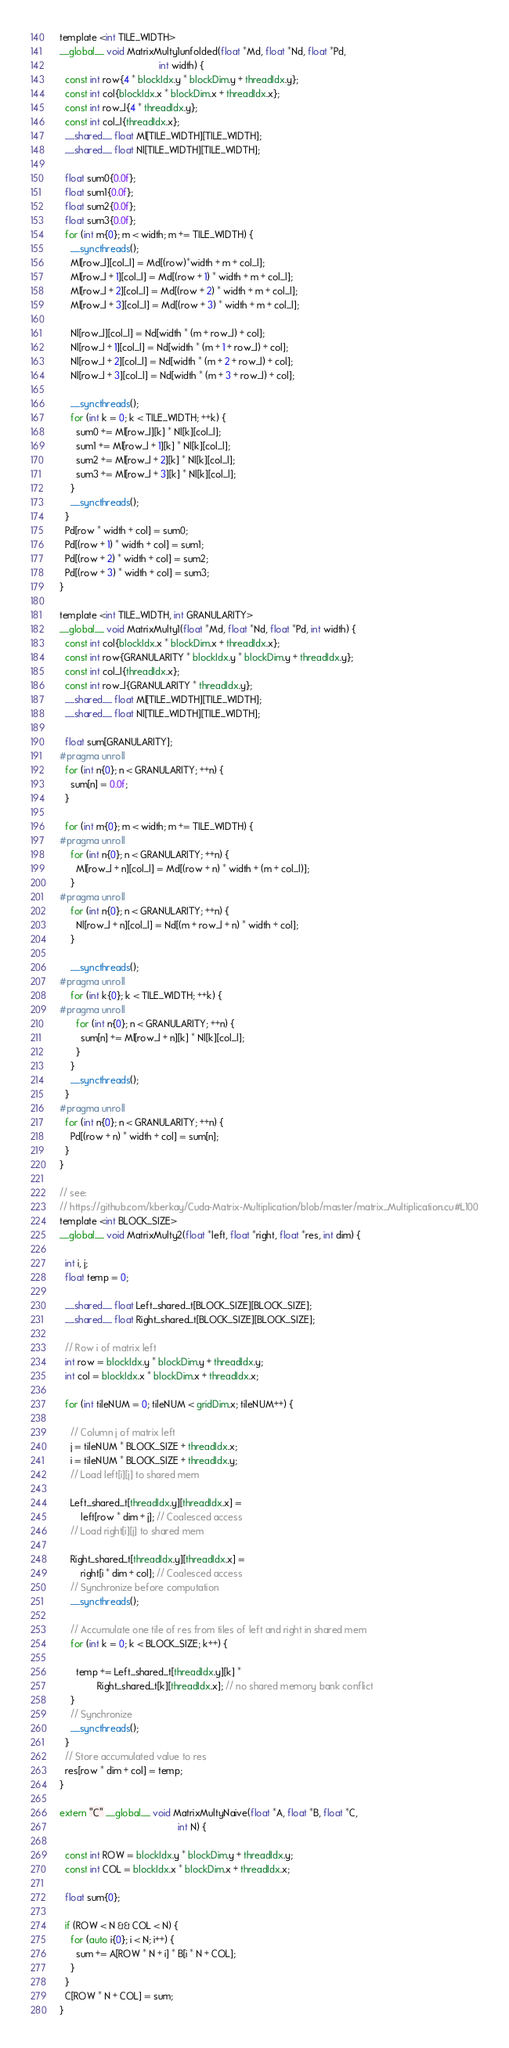<code> <loc_0><loc_0><loc_500><loc_500><_Cuda_>template <int TILE_WIDTH>
__global__ void MatrixMulty1unfolded(float *Md, float *Nd, float *Pd,
                                     int width) {
  const int row{4 * blockIdx.y * blockDim.y + threadIdx.y};
  const int col{blockIdx.x * blockDim.x + threadIdx.x};
  const int row_l{4 * threadIdx.y};
  const int col_l{threadIdx.x};
  __shared__ float Ml[TILE_WIDTH][TILE_WIDTH];
  __shared__ float Nl[TILE_WIDTH][TILE_WIDTH];

  float sum0{0.0f};
  float sum1{0.0f};
  float sum2{0.0f};
  float sum3{0.0f};
  for (int m{0}; m < width; m += TILE_WIDTH) {
    __syncthreads();
    Ml[row_l][col_l] = Md[(row)*width + m + col_l];
    Ml[row_l + 1][col_l] = Md[(row + 1) * width + m + col_l];
    Ml[row_l + 2][col_l] = Md[(row + 2) * width + m + col_l];
    Ml[row_l + 3][col_l] = Md[(row + 3) * width + m + col_l];

    Nl[row_l][col_l] = Nd[width * (m + row_l) + col];
    Nl[row_l + 1][col_l] = Nd[width * (m + 1 + row_l) + col];
    Nl[row_l + 2][col_l] = Nd[width * (m + 2 + row_l) + col];
    Nl[row_l + 3][col_l] = Nd[width * (m + 3 + row_l) + col];

    __syncthreads();
    for (int k = 0; k < TILE_WIDTH; ++k) {
      sum0 += Ml[row_l][k] * Nl[k][col_l];
      sum1 += Ml[row_l + 1][k] * Nl[k][col_l];
      sum2 += Ml[row_l + 2][k] * Nl[k][col_l];
      sum3 += Ml[row_l + 3][k] * Nl[k][col_l];
    }
    __syncthreads();
  }
  Pd[row * width + col] = sum0;
  Pd[(row + 1) * width + col] = sum1;
  Pd[(row + 2) * width + col] = sum2;
  Pd[(row + 3) * width + col] = sum3;
}

template <int TILE_WIDTH, int GRANULARITY>
__global__ void MatrixMulty1(float *Md, float *Nd, float *Pd, int width) {
  const int col{blockIdx.x * blockDim.x + threadIdx.x};
  const int row{GRANULARITY * blockIdx.y * blockDim.y + threadIdx.y};
  const int col_l{threadIdx.x};
  const int row_l{GRANULARITY * threadIdx.y};
  __shared__ float Ml[TILE_WIDTH][TILE_WIDTH];
  __shared__ float Nl[TILE_WIDTH][TILE_WIDTH];

  float sum[GRANULARITY];
#pragma unroll
  for (int n{0}; n < GRANULARITY; ++n) {
    sum[n] = 0.0f;
  }

  for (int m{0}; m < width; m += TILE_WIDTH) {
#pragma unroll
    for (int n{0}; n < GRANULARITY; ++n) {
      Ml[row_l + n][col_l] = Md[(row + n) * width + (m + col_l)];
    }
#pragma unroll
    for (int n{0}; n < GRANULARITY; ++n) {
      Nl[row_l + n][col_l] = Nd[(m + row_l + n) * width + col];
    }

    __syncthreads();
#pragma unroll
    for (int k{0}; k < TILE_WIDTH; ++k) {
#pragma unroll
      for (int n{0}; n < GRANULARITY; ++n) {
        sum[n] += Ml[row_l + n][k] * Nl[k][col_l];
      }
    }
    __syncthreads();
  }
#pragma unroll
  for (int n{0}; n < GRANULARITY; ++n) {
    Pd[(row + n) * width + col] = sum[n];
  }
}

// see:
// https://github.com/kberkay/Cuda-Matrix-Multiplication/blob/master/matrix_Multiplication.cu#L100
template <int BLOCK_SIZE>
__global__ void MatrixMulty2(float *left, float *right, float *res, int dim) {

  int i, j;
  float temp = 0;

  __shared__ float Left_shared_t[BLOCK_SIZE][BLOCK_SIZE];
  __shared__ float Right_shared_t[BLOCK_SIZE][BLOCK_SIZE];

  // Row i of matrix left
  int row = blockIdx.y * blockDim.y + threadIdx.y;
  int col = blockIdx.x * blockDim.x + threadIdx.x;

  for (int tileNUM = 0; tileNUM < gridDim.x; tileNUM++) {

    // Column j of matrix left
    j = tileNUM * BLOCK_SIZE + threadIdx.x;
    i = tileNUM * BLOCK_SIZE + threadIdx.y;
    // Load left[i][j] to shared mem

    Left_shared_t[threadIdx.y][threadIdx.x] =
        left[row * dim + j]; // Coalesced access
    // Load right[i][j] to shared mem

    Right_shared_t[threadIdx.y][threadIdx.x] =
        right[i * dim + col]; // Coalesced access
    // Synchronize before computation
    __syncthreads();

    // Accumulate one tile of res from tiles of left and right in shared mem
    for (int k = 0; k < BLOCK_SIZE; k++) {

      temp += Left_shared_t[threadIdx.y][k] *
              Right_shared_t[k][threadIdx.x]; // no shared memory bank conflict
    }
    // Synchronize
    __syncthreads();
  }
  // Store accumulated value to res
  res[row * dim + col] = temp;
}

extern "C" __global__ void MatrixMultyNaive(float *A, float *B, float *C,
                                            int N) {

  const int ROW = blockIdx.y * blockDim.y + threadIdx.y;
  const int COL = blockIdx.x * blockDim.x + threadIdx.x;

  float sum{0};

  if (ROW < N && COL < N) {
    for (auto i{0}; i < N; i++) {
      sum += A[ROW * N + i] * B[i * N + COL];
    }
  }
  C[ROW * N + COL] = sum;
}
</code> 